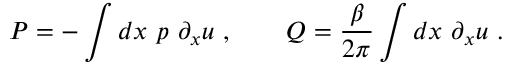<formula> <loc_0><loc_0><loc_500><loc_500>P = - \int d x \ p \ \partial _ { x } u \ , \quad Q = { \frac { \beta } { 2 \pi } } \int d x \ \partial _ { x } u \ .</formula> 